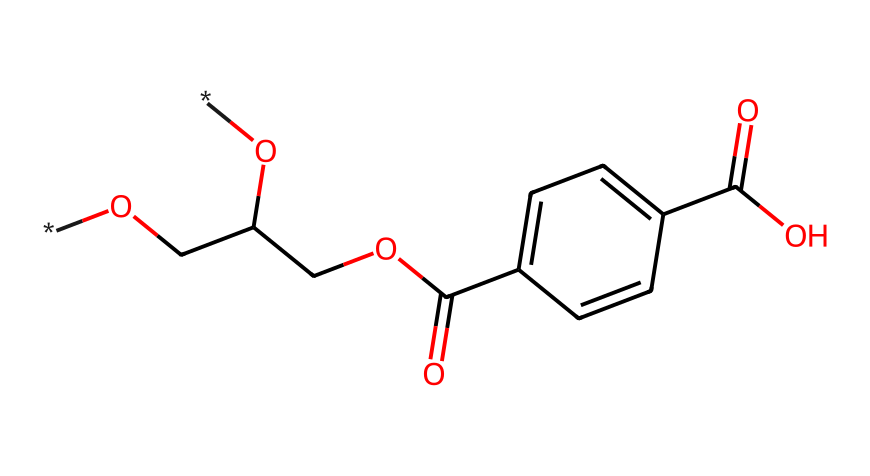What is the primary functional group present in PET? The structure contains an ester functional group, indicated by the presence of the -CO-O- linkage in the repeated units, which is characteristic of polyesters like PET.
Answer: ester How many carbon atoms are in the structural representation? Counting the carbon atoms depicted in the SMILES representation, there are a total of 10 carbon atoms indicated by their presence in various parts of the molecule including the aromatic ring and the aliphatic chains.
Answer: 10 What is the significance of the aromatic ring in PET? The aromatic ring contributes to the rigidity and thermal stability of the polymer. Specifically, the presence of the benzene-like structure affects the overall properties including mechanical strength and resistance to heat.
Answer: rigidity What type of polymer is polyethylene terephthalate? The classification of polyethylene terephthalate is as a thermoplastic, which means it can be re-melted and re-molded upon heating, allowing for versatility in manufacturing and recycling.
Answer: thermoplastic How many functional groups are present in the chemical structure? In the given structure, there are two functional groups: one ester and one carboxylic acid group, which play roles in the polymer's reaction mechanisms and properties.
Answer: two What is the role of the hydroxyl groups in the structure of PET? The hydroxyl groups (-OH) serve as sites for hydrogen bonding, which enhances the intermolecular forces, leading to better solubility and processing characteristics.
Answer: hydrogen bonding 